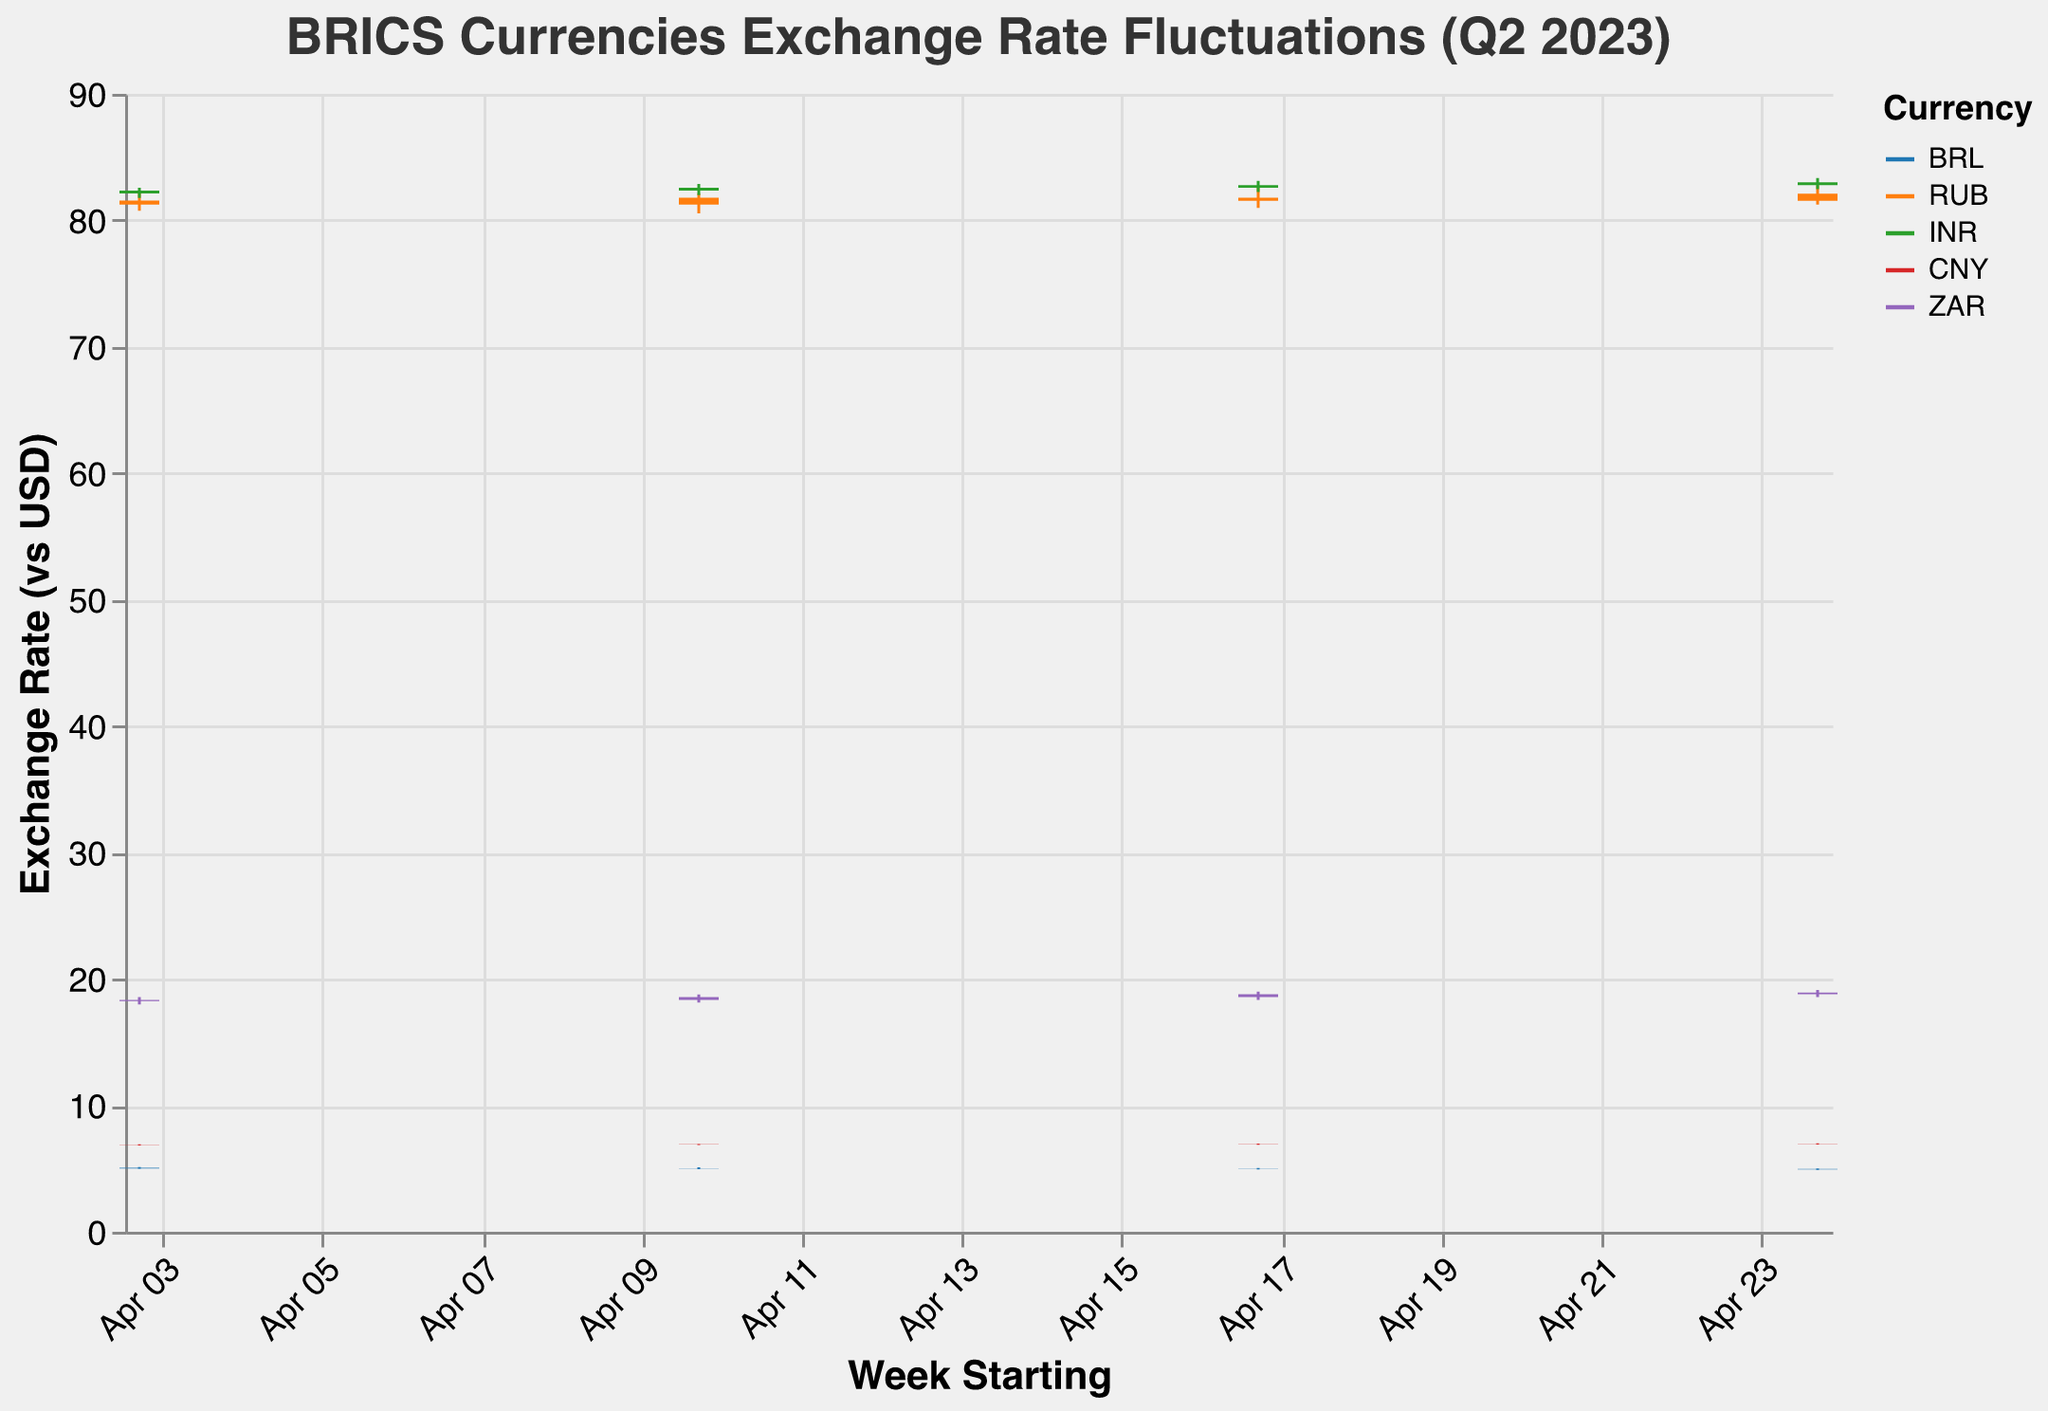What is the title of the chart? The title is usually displayed at the top of the chart and provides a summary of what the chart represents. In this case, the title is "BRICS Currencies Exchange Rate Fluctuations (Q2 2023)"
Answer: BRICS Currencies Exchange Rate Fluctuations (Q2 2023) How many different currencies are represented in the chart? The chart uses colors to differentiate between the currencies. By looking at the legend, we can count the number of different currencies.
Answer: 5 What color represents the BRL currency? The color corresponding to BRL can be found by looking at the legend, which shows different colors for different currencies.
Answer: #1f77b4 Which currency had the highest exchange rate value against the US dollar in the given quarter? To find the highest exchange rate, we need to look for the maximum value in the "High" column for all currencies. In this case, RUB had a high of 82.7654, which is the highest.
Answer: RUB What was the opening exchange rate of the Indian Rupee (INR) on April 17, 2023? Locate the INR data for the specific week (2023-04-17) and check the "Open" value for that date. The opening exchange rate is 82.5678.
Answer: 82.5678 Which currency showed the greatest fluctuation in exchange rates during the week of April 24, 2023? For each currency, calculate the difference between the high and low values for the week of April 24, 2023: BRL (5.0123 - 4.8987 = 0.1136), RUB (82.7654 - 81.2345 = 1.5309), INR (83.3456 - 82.4567 = 0.8889), CNY (6.9876 - 6.8987 = 0.0889), ZAR (19.1234 - 18.5678 = 0.5556). RUB has the greatest fluctuation.
Answer: RUB What is the range (difference between high and low) of CNY for the week starting April 10, 2023? Find the high and low values for CNY for the week of April 10 and calculate the difference. The high is 6.9456, and the low is 6.8543. The range is 6.9456 - 6.8543 = 0.0913.
Answer: 0.0913 How did the exchange rate for ZAR change from the week starting April 3 to the week starting April 10? Compare the closing values of ZAR for the weeks starting April 3 and April 10. The closing rate went from 18.3456 on April 3 to 18.5678 on April 10. The change is 18.5678 - 18.3456 = 0.2222.
Answer: Increased by 0.2222 Which week did the BRL have its lowest closing rate during the quarter? Look at the closing rates for BRL across all weeks and find the minimum value. BRL had its lowest closing rate of 4.9321 during the week starting April 24, 2023.
Answer: April 24, 2023 What is the average closing rate for the INR over the given weeks? Sum up the closing rates for INR for all the weeks and divide by the number of weeks. (82.3456 + 82.5678 + 82.7890 + 83.0123) / 4 = 82.6787.
Answer: 82.6787 